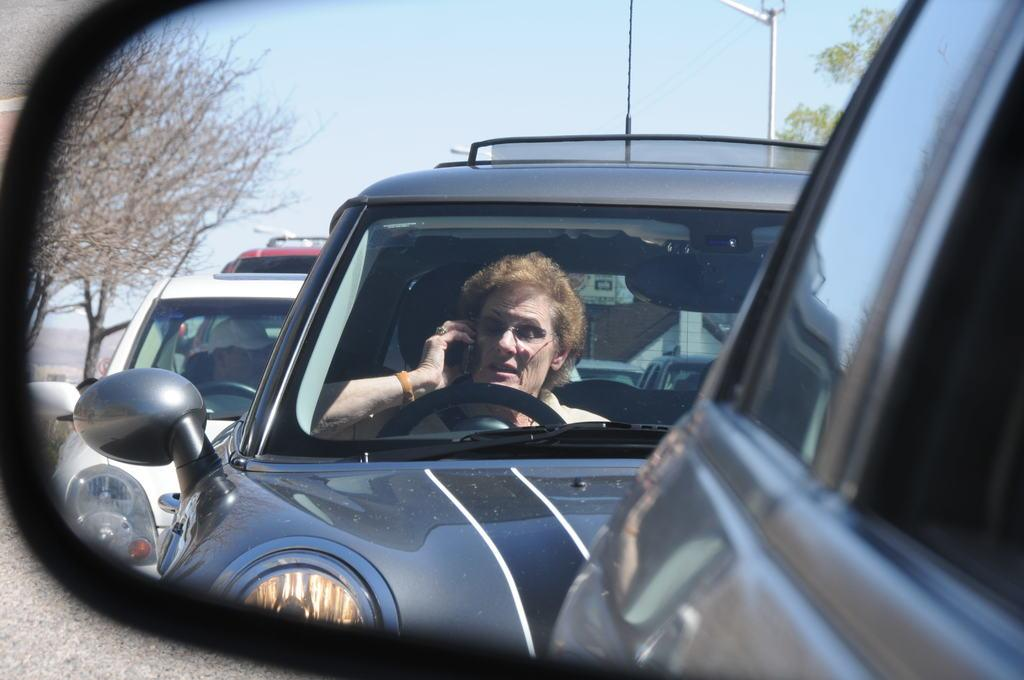What is the main subject of the image? There is a person sitting inside a car in the image. Can you describe the surroundings of the car? There are other cars, trees, a pole with wires, and the sky visible in the image. How is the image presented? The image is entirely reflected on a mirror. What type of furniture can be seen in the image? There is no furniture present in the image; it features a person sitting inside a car and its surroundings. 